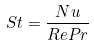<formula> <loc_0><loc_0><loc_500><loc_500>S t = \frac { N u } { R e P r }</formula> 